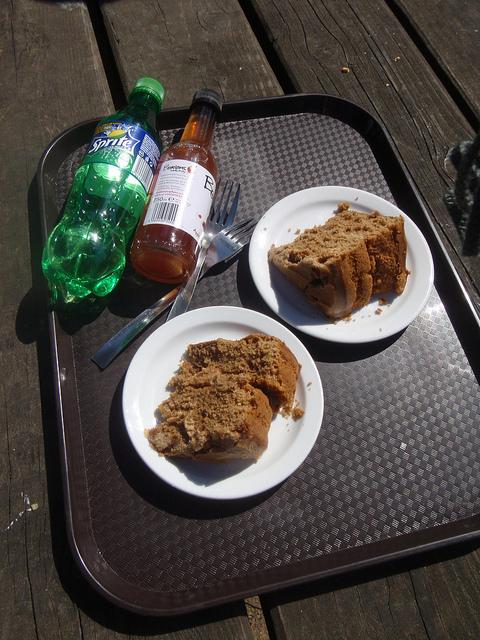What kind of countertop is this?
Write a very short answer. Wood. How many of the utensils are on the tray?
Be succinct. 2. What's to drink?
Give a very brief answer. Sprite. What color does the plate have that none of the food on it does?
Keep it brief. White. What kind of plates are these?
Answer briefly. Paper. Do you see a reflection?
Quick response, please. No. What is sitting on the white plates?
Be succinct. Cake. 